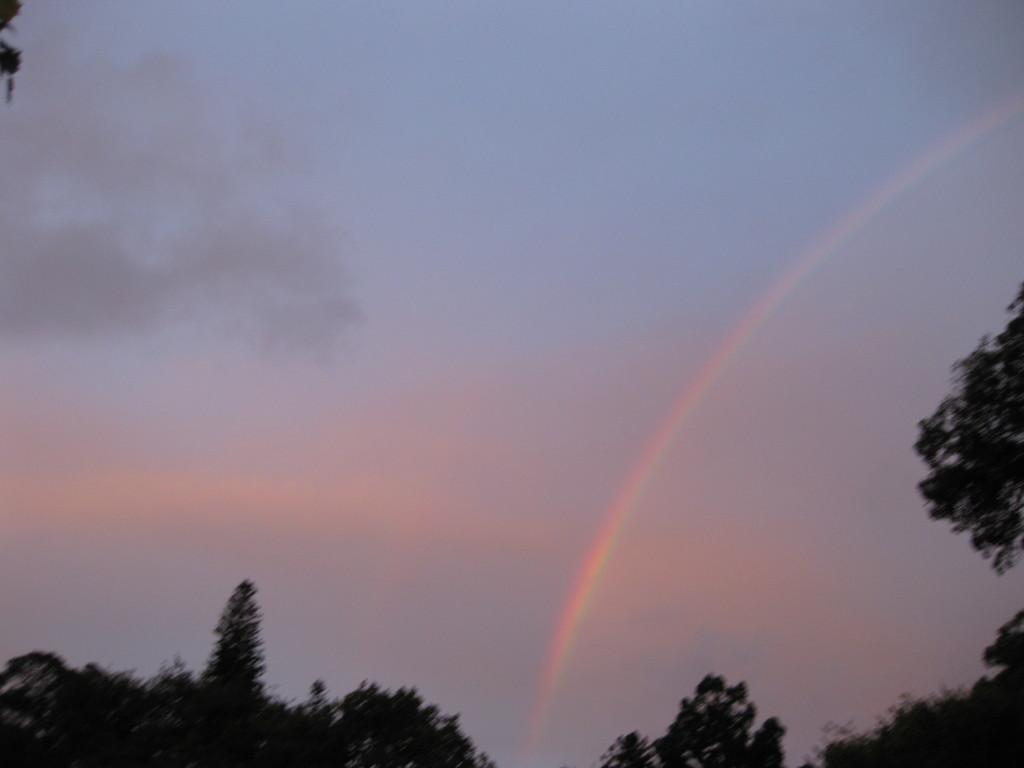What type of natural elements can be seen in the image? There are trees in the image. What atmospheric phenomenon is visible in the image? There is a rainbow in the image. What part of the natural environment is visible in the image? The sky is visible in the image. What grade did the creator of the image receive for their work? There is no information about the creator of the image or any grades associated with it, so this question cannot be answered. 